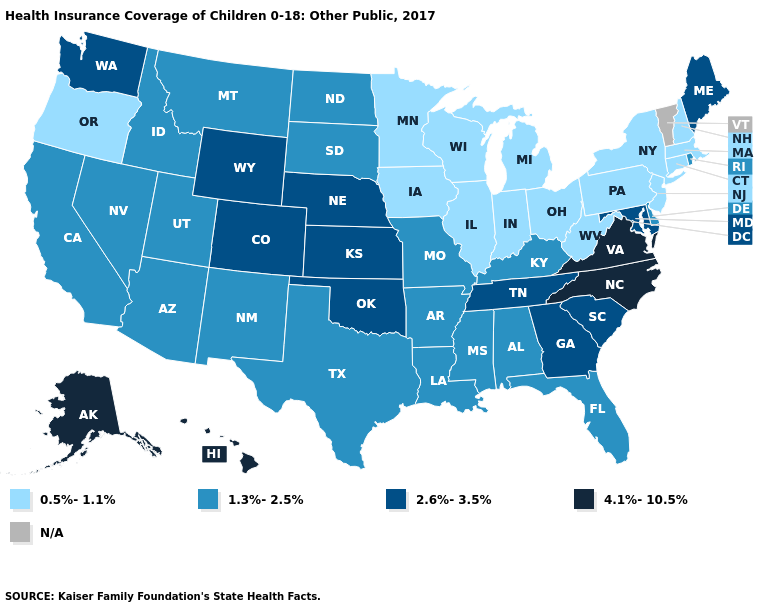Among the states that border Delaware , does Maryland have the highest value?
Be succinct. Yes. Does the first symbol in the legend represent the smallest category?
Write a very short answer. Yes. What is the highest value in states that border West Virginia?
Quick response, please. 4.1%-10.5%. What is the lowest value in states that border Tennessee?
Keep it brief. 1.3%-2.5%. Which states have the lowest value in the West?
Write a very short answer. Oregon. What is the value of Maine?
Give a very brief answer. 2.6%-3.5%. Name the states that have a value in the range 0.5%-1.1%?
Keep it brief. Connecticut, Illinois, Indiana, Iowa, Massachusetts, Michigan, Minnesota, New Hampshire, New Jersey, New York, Ohio, Oregon, Pennsylvania, West Virginia, Wisconsin. What is the value of Maine?
Answer briefly. 2.6%-3.5%. Does Maine have the highest value in the Northeast?
Quick response, please. Yes. Name the states that have a value in the range 4.1%-10.5%?
Answer briefly. Alaska, Hawaii, North Carolina, Virginia. Name the states that have a value in the range 4.1%-10.5%?
Short answer required. Alaska, Hawaii, North Carolina, Virginia. What is the value of Vermont?
Answer briefly. N/A. Does the map have missing data?
Give a very brief answer. Yes. Does the first symbol in the legend represent the smallest category?
Short answer required. Yes. 